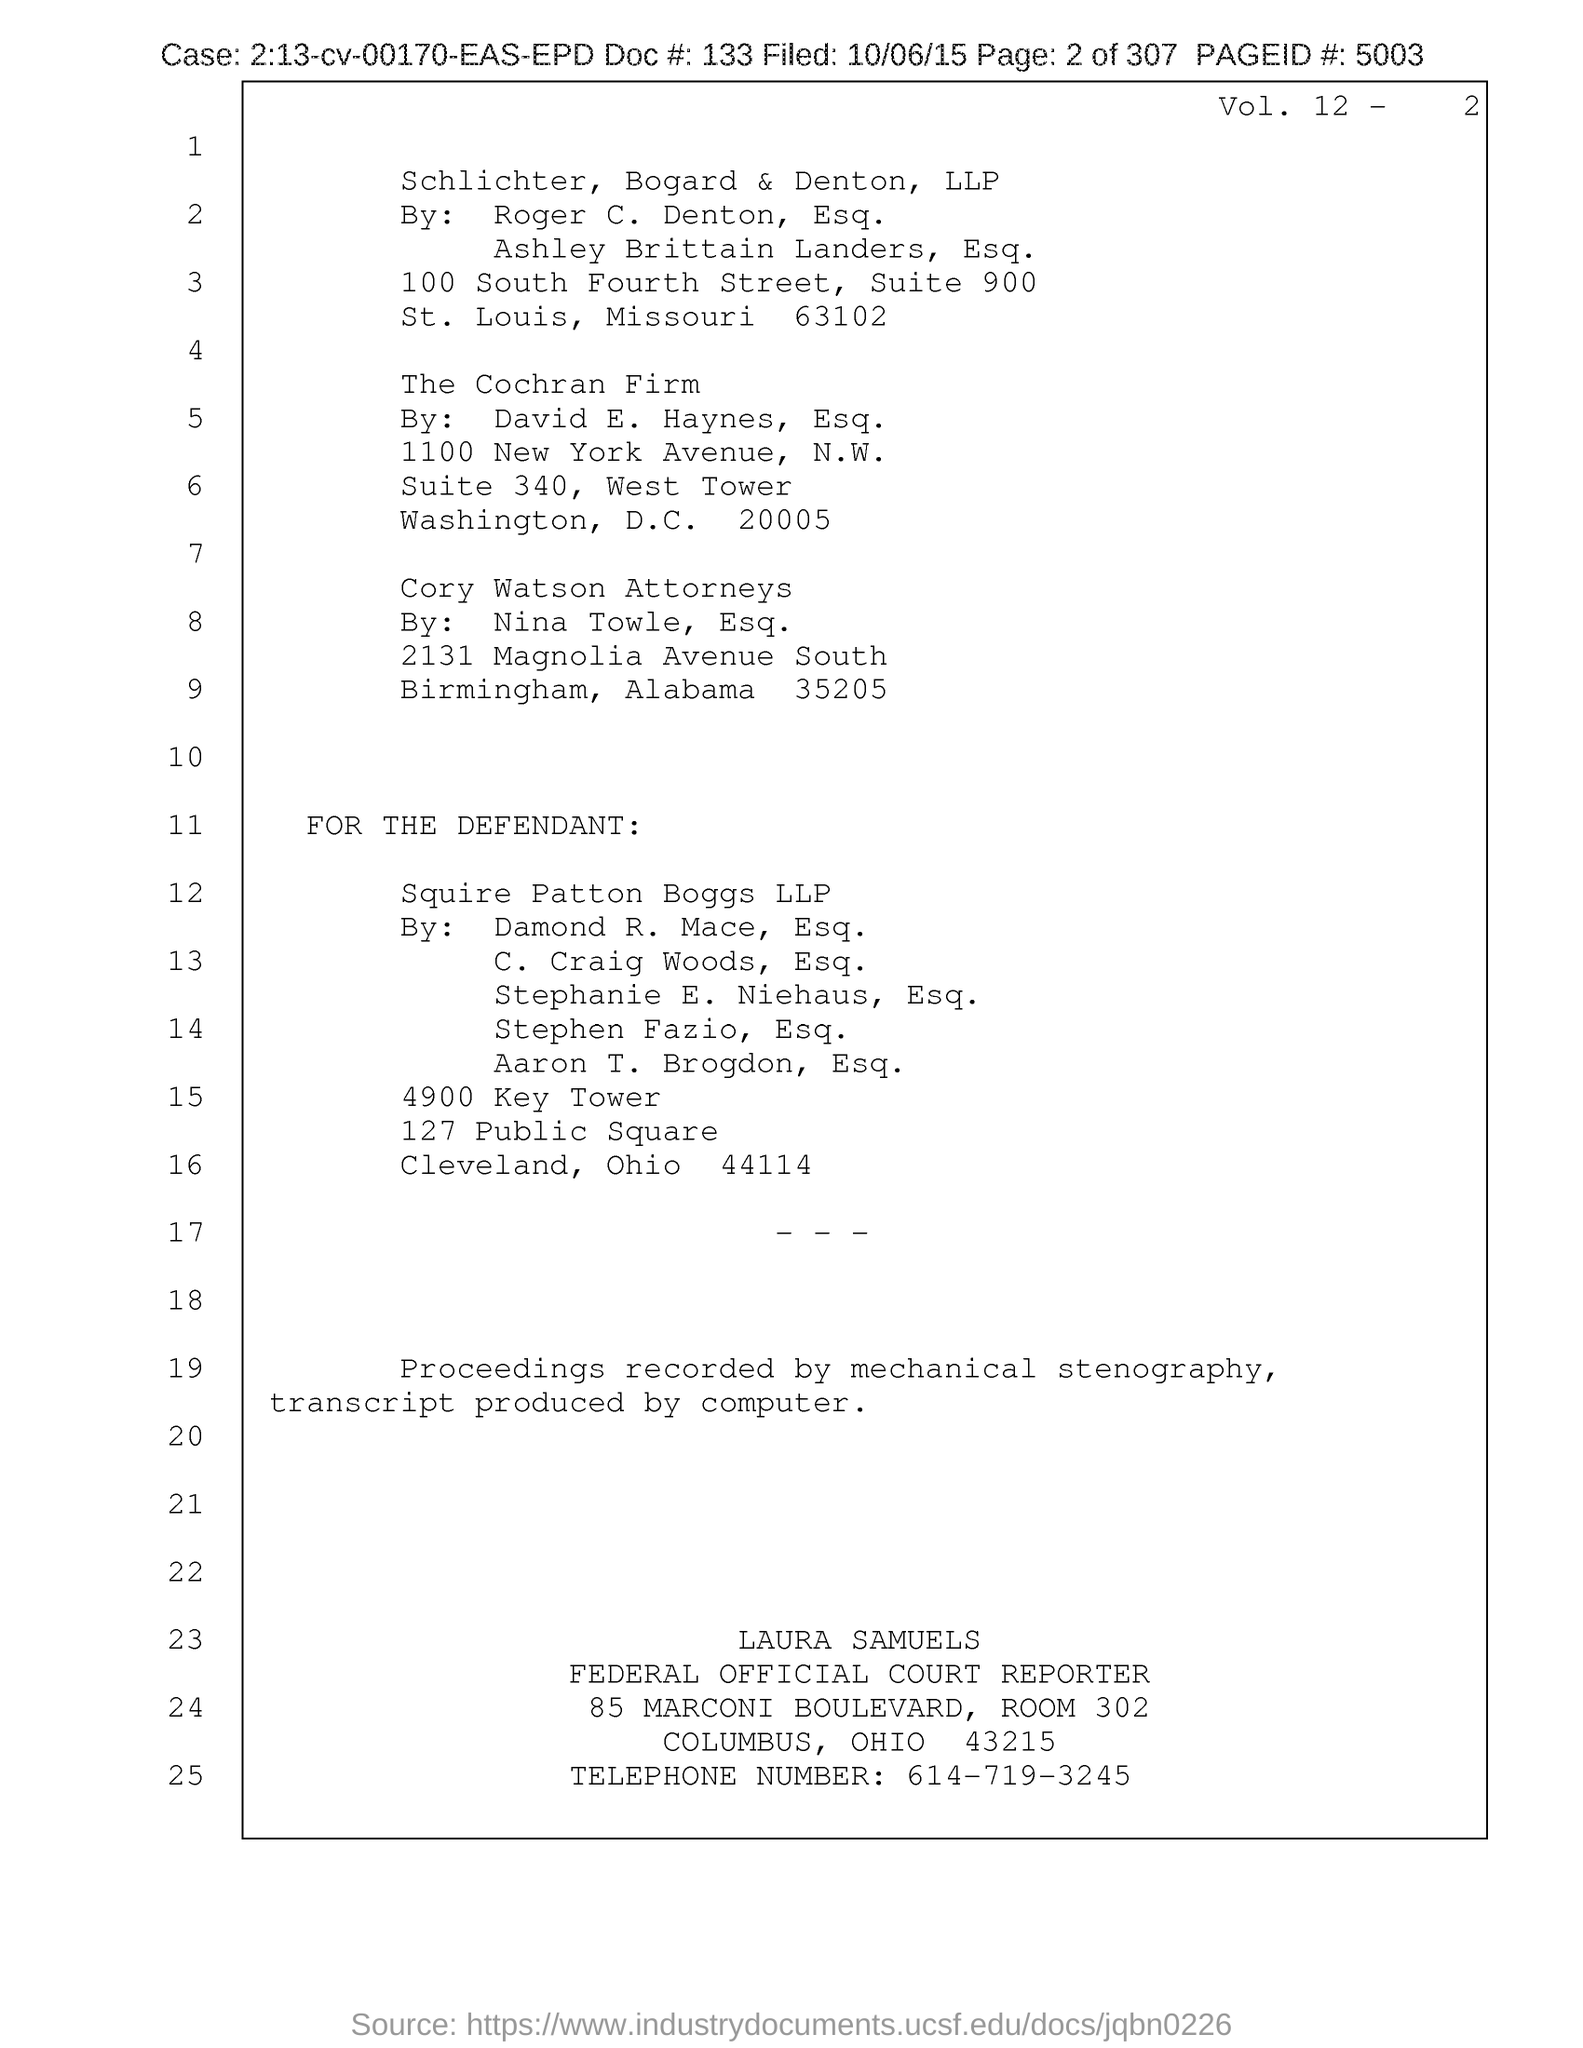What is the page id?
Your answer should be compact. 5003. What is the telephone number?
Your answer should be very brief. 614-719-3245. 